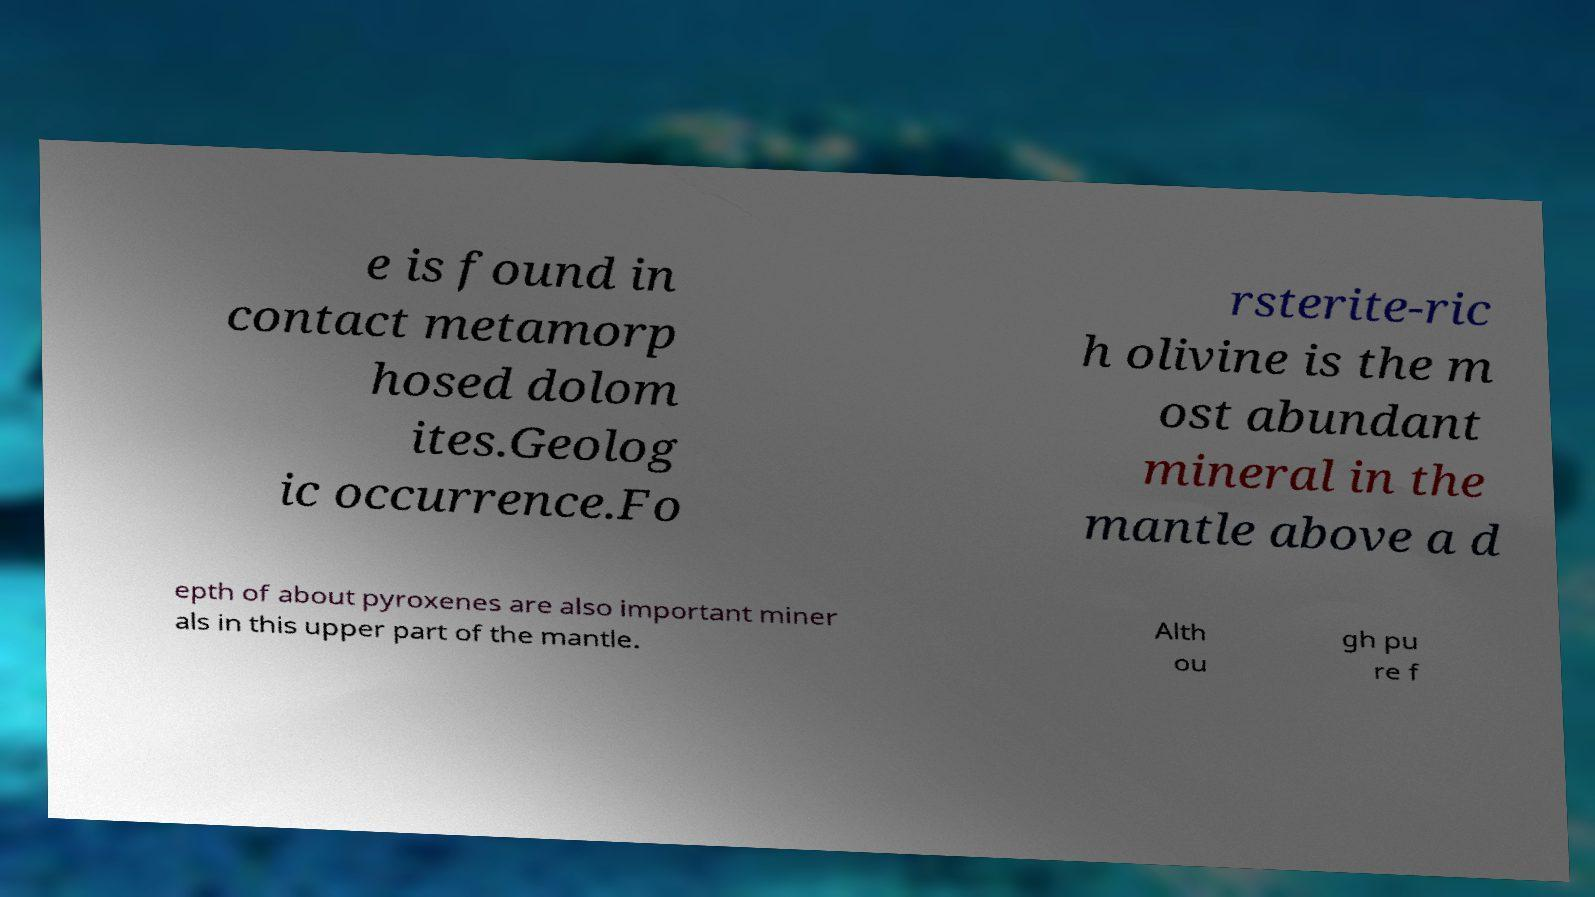Can you accurately transcribe the text from the provided image for me? e is found in contact metamorp hosed dolom ites.Geolog ic occurrence.Fo rsterite-ric h olivine is the m ost abundant mineral in the mantle above a d epth of about pyroxenes are also important miner als in this upper part of the mantle. Alth ou gh pu re f 